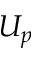<formula> <loc_0><loc_0><loc_500><loc_500>U _ { p }</formula> 